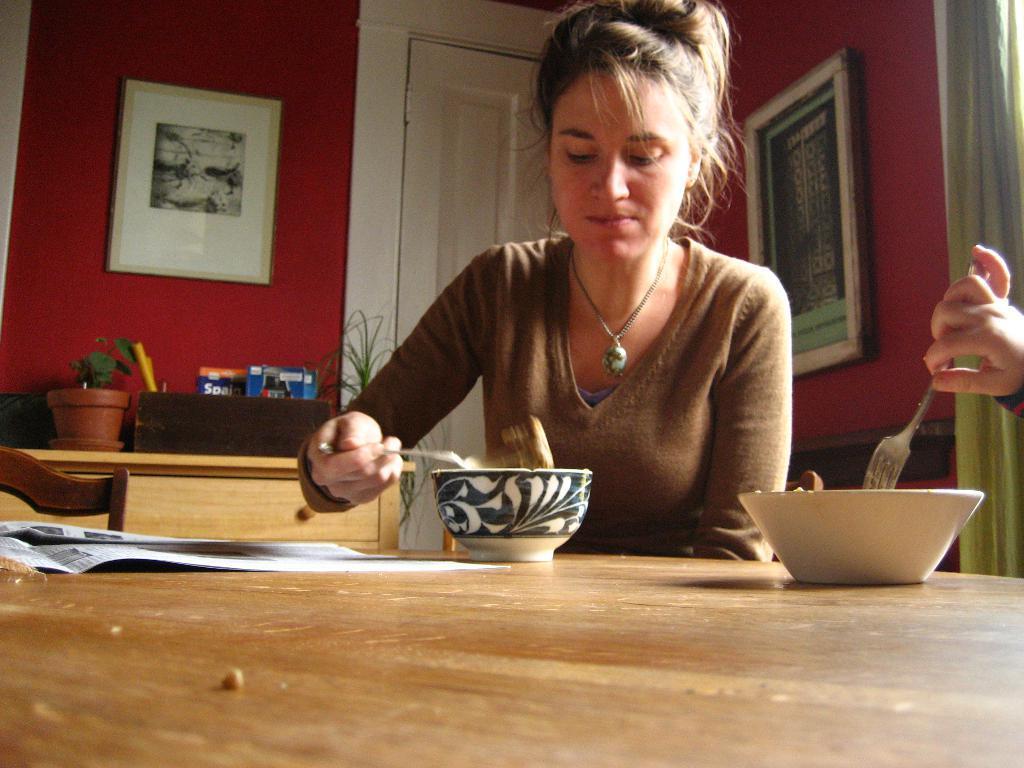Could you give a brief overview of what you see in this image? This is a picture taken in a room, the woman in brown t shirt was sitting on a chair in front of the woman there is a table on the table there are bowl and paper. Behind the woman there is a white door and a wall on the wall there are photo frames. In front of the wall there is other wooden table on the table there are books and flower pot. 